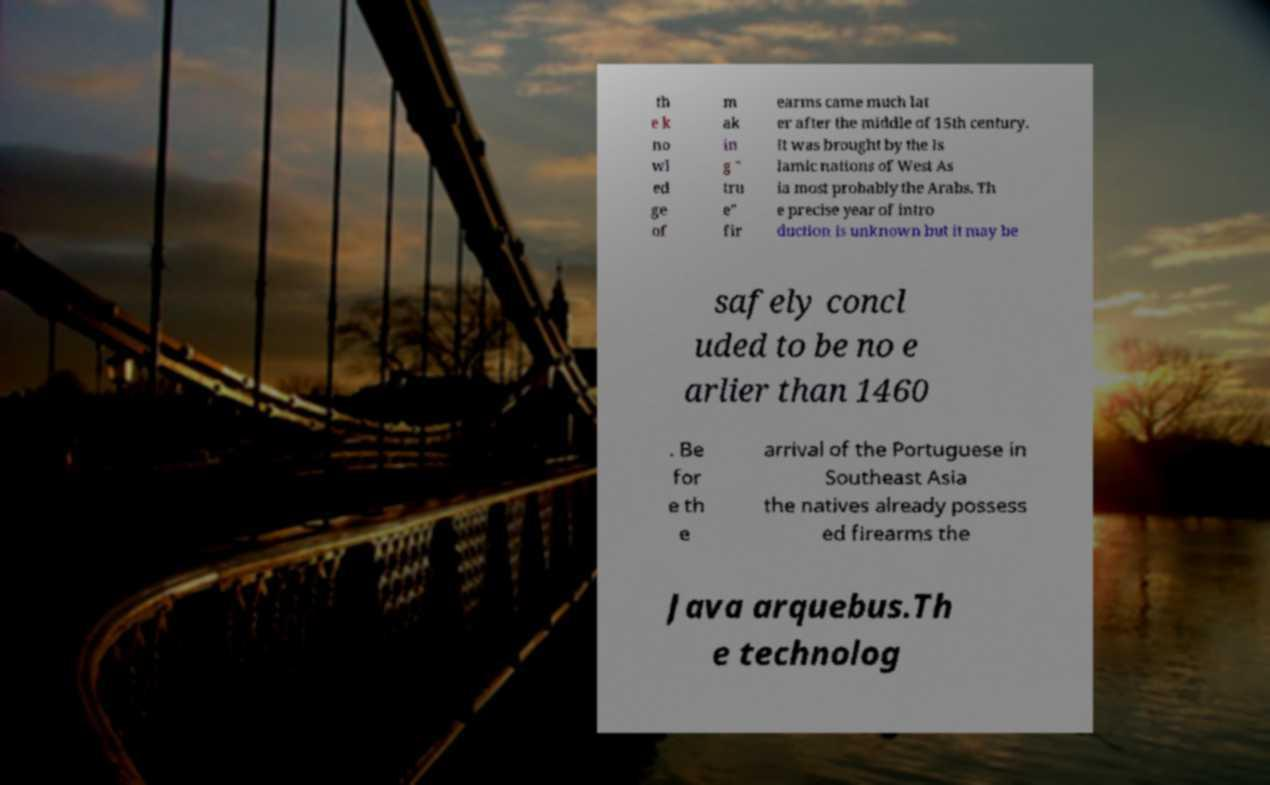Please identify and transcribe the text found in this image. th e k no wl ed ge of m ak in g " tru e" fir earms came much lat er after the middle of 15th century. It was brought by the Is lamic nations of West As ia most probably the Arabs. Th e precise year of intro duction is unknown but it may be safely concl uded to be no e arlier than 1460 . Be for e th e arrival of the Portuguese in Southeast Asia the natives already possess ed firearms the Java arquebus.Th e technolog 